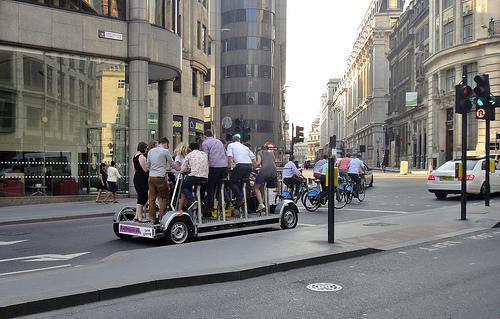How many people are walking on the sidewalk behind the cart?
Give a very brief answer. 2. 